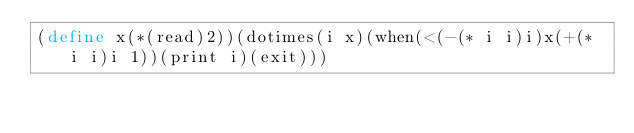<code> <loc_0><loc_0><loc_500><loc_500><_Scheme_>(define x(*(read)2))(dotimes(i x)(when(<(-(* i i)i)x(+(* i i)i 1))(print i)(exit)))</code> 